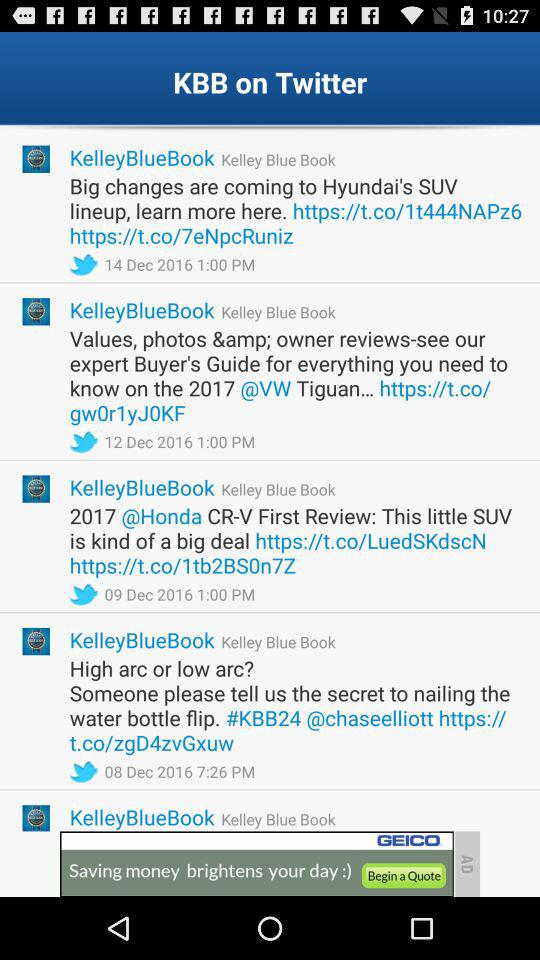What is the fair market range? The fair market range is $24,330-$27,163. 